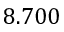<formula> <loc_0><loc_0><loc_500><loc_500>8 . 7 0 0</formula> 